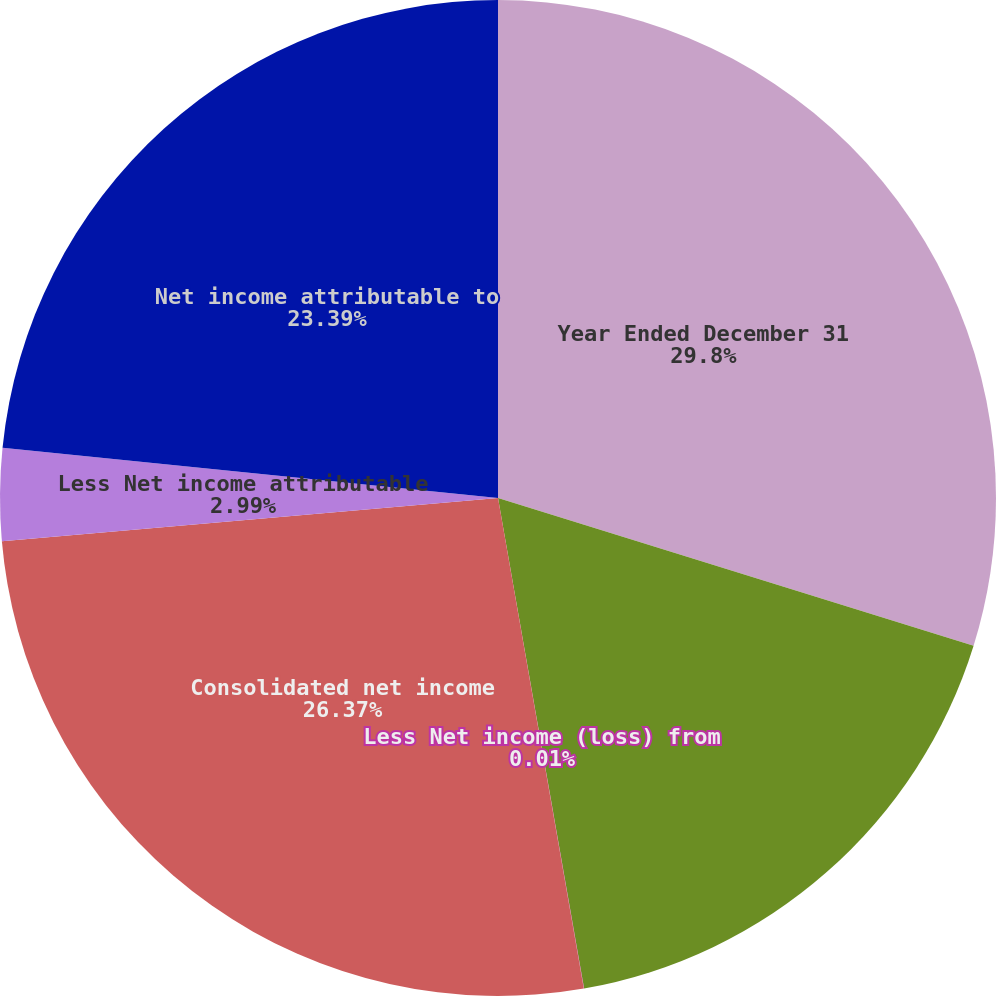Convert chart to OTSL. <chart><loc_0><loc_0><loc_500><loc_500><pie_chart><fcel>Year Ended December 31<fcel>Net income from continuing<fcel>Less Net income (loss) from<fcel>Consolidated net income<fcel>Less Net income attributable<fcel>Net income attributable to<nl><fcel>29.79%<fcel>17.44%<fcel>0.01%<fcel>26.37%<fcel>2.99%<fcel>23.39%<nl></chart> 